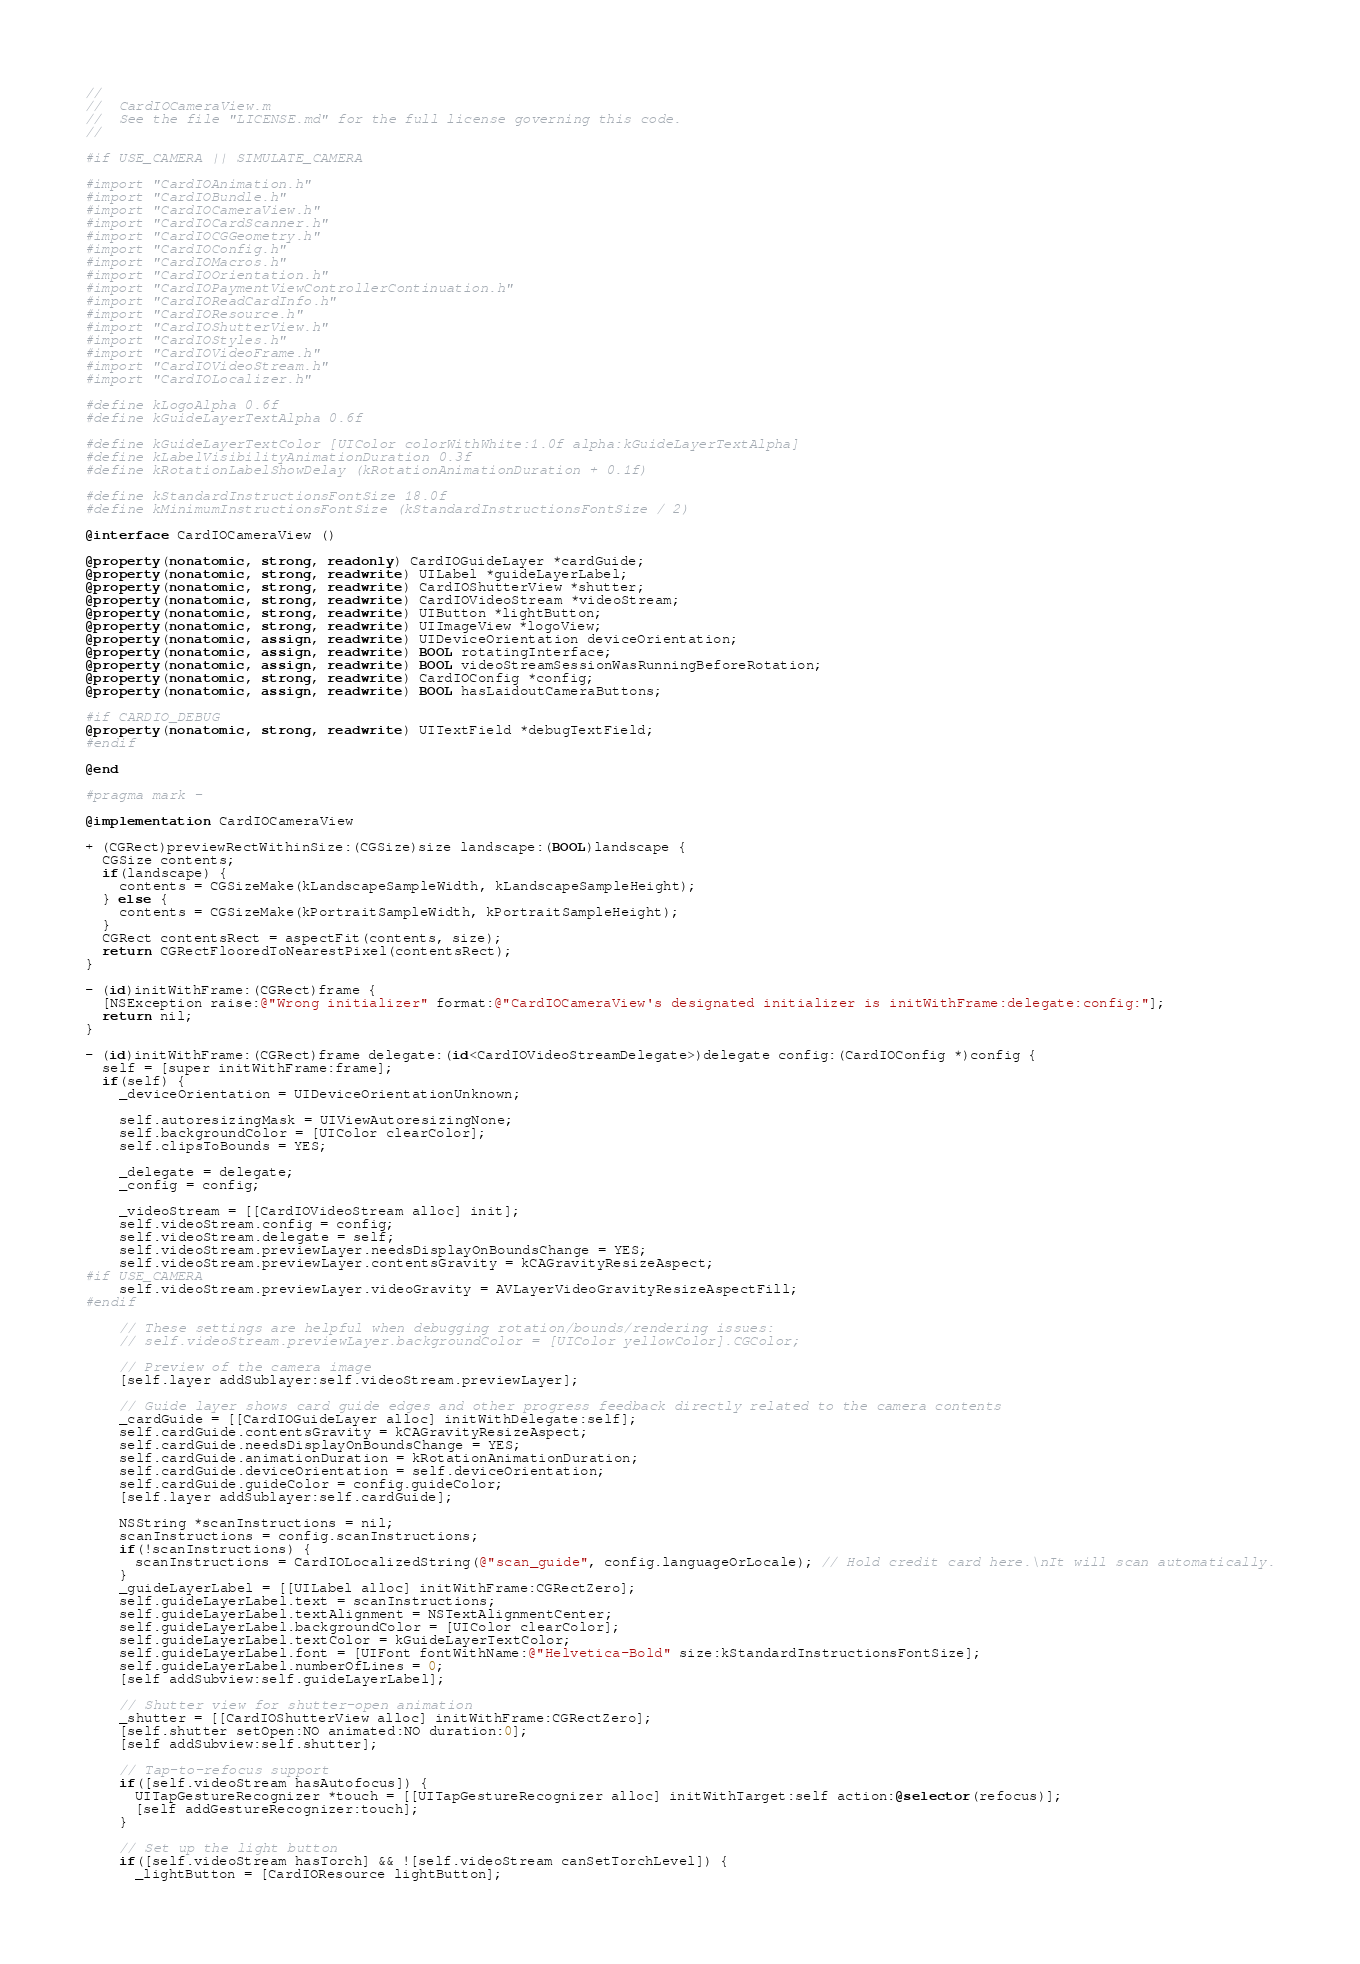Convert code to text. <code><loc_0><loc_0><loc_500><loc_500><_ObjectiveC_>//
//  CardIOCameraView.m
//  See the file "LICENSE.md" for the full license governing this code.
//

#if USE_CAMERA || SIMULATE_CAMERA

#import "CardIOAnimation.h"
#import "CardIOBundle.h"
#import "CardIOCameraView.h"
#import "CardIOCardScanner.h"
#import "CardIOCGGeometry.h"
#import "CardIOConfig.h"
#import "CardIOMacros.h"
#import "CardIOOrientation.h"
#import "CardIOPaymentViewControllerContinuation.h"
#import "CardIOReadCardInfo.h"
#import "CardIOResource.h"
#import "CardIOShutterView.h"
#import "CardIOStyles.h"
#import "CardIOVideoFrame.h"
#import "CardIOVideoStream.h"
#import "CardIOLocalizer.h"

#define kLogoAlpha 0.6f
#define kGuideLayerTextAlpha 0.6f

#define kGuideLayerTextColor [UIColor colorWithWhite:1.0f alpha:kGuideLayerTextAlpha]
#define kLabelVisibilityAnimationDuration 0.3f
#define kRotationLabelShowDelay (kRotationAnimationDuration + 0.1f)

#define kStandardInstructionsFontSize 18.0f
#define kMinimumInstructionsFontSize (kStandardInstructionsFontSize / 2)

@interface CardIOCameraView ()

@property(nonatomic, strong, readonly) CardIOGuideLayer *cardGuide;
@property(nonatomic, strong, readwrite) UILabel *guideLayerLabel;
@property(nonatomic, strong, readwrite) CardIOShutterView *shutter;
@property(nonatomic, strong, readwrite) CardIOVideoStream *videoStream;
@property(nonatomic, strong, readwrite) UIButton *lightButton;
@property(nonatomic, strong, readwrite) UIImageView *logoView;
@property(nonatomic, assign, readwrite) UIDeviceOrientation deviceOrientation;
@property(nonatomic, assign, readwrite) BOOL rotatingInterface;
@property(nonatomic, assign, readwrite) BOOL videoStreamSessionWasRunningBeforeRotation;
@property(nonatomic, strong, readwrite) CardIOConfig *config;
@property(nonatomic, assign, readwrite) BOOL hasLaidoutCameraButtons;

#if CARDIO_DEBUG
@property(nonatomic, strong, readwrite) UITextField *debugTextField;
#endif

@end

#pragma mark -

@implementation CardIOCameraView

+ (CGRect)previewRectWithinSize:(CGSize)size landscape:(BOOL)landscape {
  CGSize contents;
  if(landscape) {
    contents = CGSizeMake(kLandscapeSampleWidth, kLandscapeSampleHeight);
  } else {
    contents = CGSizeMake(kPortraitSampleWidth, kPortraitSampleHeight);
  }
  CGRect contentsRect = aspectFit(contents, size);
  return CGRectFlooredToNearestPixel(contentsRect);
}

- (id)initWithFrame:(CGRect)frame {
  [NSException raise:@"Wrong initializer" format:@"CardIOCameraView's designated initializer is initWithFrame:delegate:config:"];
  return nil;
}

- (id)initWithFrame:(CGRect)frame delegate:(id<CardIOVideoStreamDelegate>)delegate config:(CardIOConfig *)config {
  self = [super initWithFrame:frame];
  if(self) {
    _deviceOrientation = UIDeviceOrientationUnknown;

    self.autoresizingMask = UIViewAutoresizingNone;
    self.backgroundColor = [UIColor clearColor];
    self.clipsToBounds = YES;

    _delegate = delegate;
    _config = config;

    _videoStream = [[CardIOVideoStream alloc] init];
    self.videoStream.config = config;
    self.videoStream.delegate = self;
    self.videoStream.previewLayer.needsDisplayOnBoundsChange = YES;
    self.videoStream.previewLayer.contentsGravity = kCAGravityResizeAspect;
#if USE_CAMERA
    self.videoStream.previewLayer.videoGravity = AVLayerVideoGravityResizeAspectFill;
#endif
    
    // These settings are helpful when debugging rotation/bounds/rendering issues:
    // self.videoStream.previewLayer.backgroundColor = [UIColor yellowColor].CGColor;

    // Preview of the camera image
    [self.layer addSublayer:self.videoStream.previewLayer];

    // Guide layer shows card guide edges and other progress feedback directly related to the camera contents
    _cardGuide = [[CardIOGuideLayer alloc] initWithDelegate:self];
    self.cardGuide.contentsGravity = kCAGravityResizeAspect;
    self.cardGuide.needsDisplayOnBoundsChange = YES;
    self.cardGuide.animationDuration = kRotationAnimationDuration;
    self.cardGuide.deviceOrientation = self.deviceOrientation;
    self.cardGuide.guideColor = config.guideColor;
    [self.layer addSublayer:self.cardGuide];

    NSString *scanInstructions = nil;
    scanInstructions = config.scanInstructions;
    if(!scanInstructions) {
      scanInstructions = CardIOLocalizedString(@"scan_guide", config.languageOrLocale); // Hold credit card here.\nIt will scan automatically.
    }
    _guideLayerLabel = [[UILabel alloc] initWithFrame:CGRectZero];
    self.guideLayerLabel.text = scanInstructions;
    self.guideLayerLabel.textAlignment = NSTextAlignmentCenter;
    self.guideLayerLabel.backgroundColor = [UIColor clearColor];
    self.guideLayerLabel.textColor = kGuideLayerTextColor;
    self.guideLayerLabel.font = [UIFont fontWithName:@"Helvetica-Bold" size:kStandardInstructionsFontSize];
    self.guideLayerLabel.numberOfLines = 0;
    [self addSubview:self.guideLayerLabel];

    // Shutter view for shutter-open animation
    _shutter = [[CardIOShutterView alloc] initWithFrame:CGRectZero];
    [self.shutter setOpen:NO animated:NO duration:0];
    [self addSubview:self.shutter];

    // Tap-to-refocus support
    if([self.videoStream hasAutofocus]) {
      UITapGestureRecognizer *touch = [[UITapGestureRecognizer alloc] initWithTarget:self action:@selector(refocus)];
      [self addGestureRecognizer:touch];
    }

    // Set up the light button
    if([self.videoStream hasTorch] && ![self.videoStream canSetTorchLevel]) {
      _lightButton = [CardIOResource lightButton];</code> 